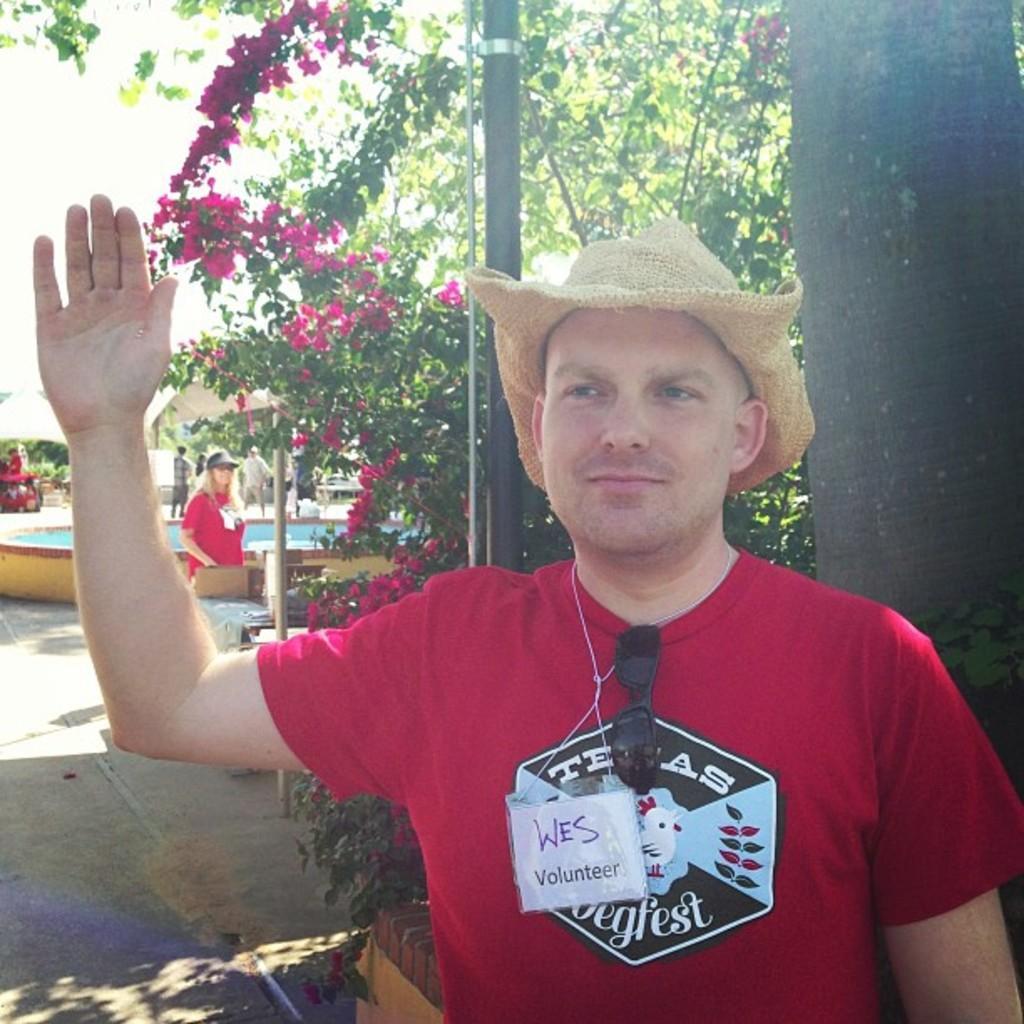Could you give a brief overview of what you see in this image? In this picture I can see a man standing is standing at the left and he is wearing a red color shirt and a cap, he has a tag and goggles and in the backdrop there is a woman standing on right and she is also wearing a red shirt and a cap, there is a plant with leaves and flowers and a fountain. The sky is clear. 